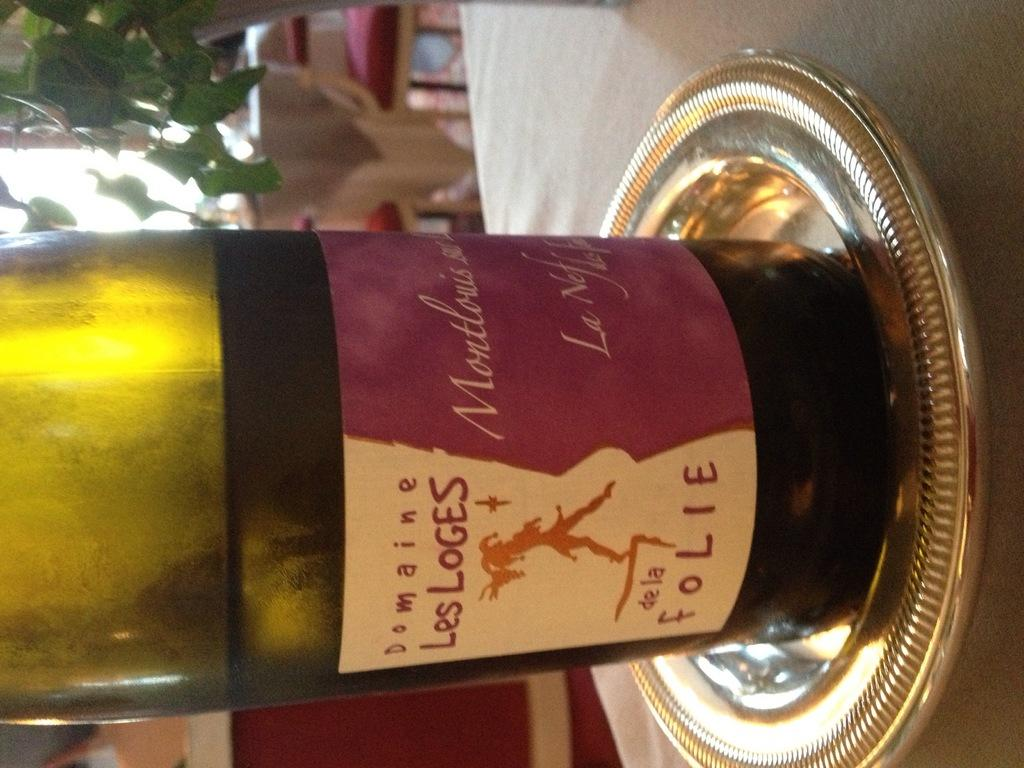<image>
Present a compact description of the photo's key features. Full bottle of Les Loges on top of a golden platter. 